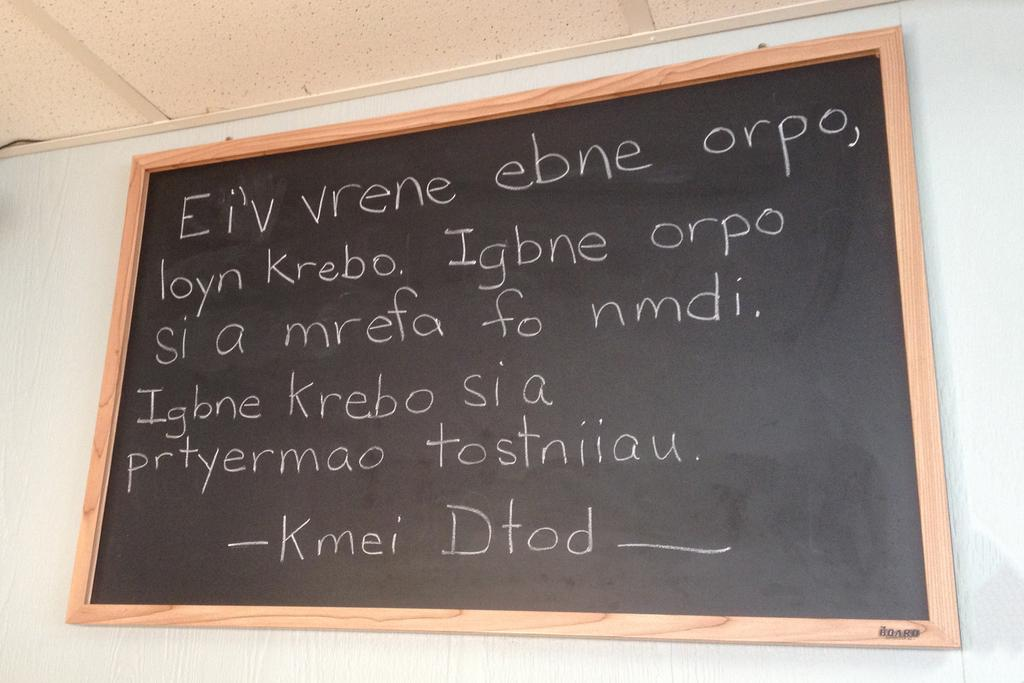What is on the wall in the image? There is a blackboard on the wall in the image. What can be seen on the blackboard? There are texts visible on the blackboard. How many family members are present in the image? There is no family member present in the image; it only features a blackboard with texts on it. 